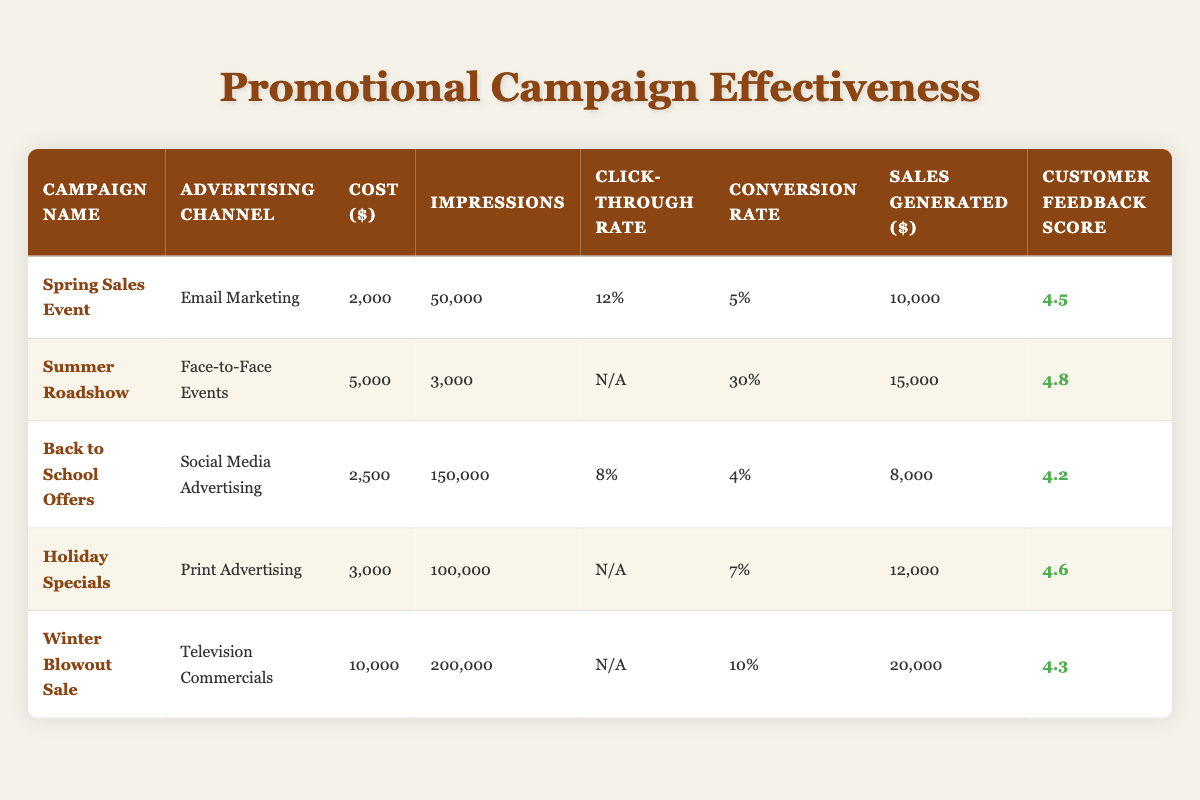What is the cost of the "Summer Roadshow" campaign? The table displays the cost of the "Summer Roadshow" campaign in the corresponding row, which is listed as $5,000.
Answer: 5000 Which advertising channel generated the highest sales? By examining the "Sales Generated" column, the highest value is $20,000 from the "Winter Blowout Sale" campaign, which used Television Commercials as the channel.
Answer: Television Commercials What is the conversion rate for the "Back to School Offers" campaign? The conversion rate for the "Back to School Offers" campaign can be found in its respective row under "Conversion Rate," which is 4%.
Answer: 4% How many impressions did the "Holiday Specials" campaign achieve? Checking the row for "Holiday Specials," the number of impressions is found in the "Impressions" column, which is 100,000.
Answer: 100000 Which campaign had the lowest customer feedback score? The lowest feedback score can be found by comparing all scores in the "Customer Feedback Score" column. "Back to School Offers" with a score of 4.2 has the lowest score.
Answer: 4.2 What channel had the highest conversion rate among all campaigns? The conversion rates are 5%, 30%, 4%, 7%, and 10%. The highest is 30% from the "Summer Roadshow" campaign, using Face-to-Face Events.
Answer: Face-to-Face Events Calculate the average sales generated across all campaigns. To find the average sales, add all sales generated: 10,000 + 15,000 + 8,000 + 12,000 + 20,000 = 65,000. Then, divide by the number of campaigns (5): 65,000 / 5 = 13,000.
Answer: 13000 Is there any campaign where the click-through rate is not available? The "Click-Through Rate" is absent (N/A) for the "Summer Roadshow," "Holiday Specials," and "Winter Blowout Sale," confirming there are campaigns without this data.
Answer: Yes Which campaign had the lowest cost per sale generated? To find the lowest cost per sale, divide the cost by sales generated for each campaign: Spring Sales Event (2000/10000=0.2), Summer Roadshow (5000/15000=0.33), Back to School Offers (2500/8000=0.3125), Holiday Specials (3000/12000=0.25), Winter Blowout Sale (10000/20000=0.5). The lowest cost per sale is from the Spring Sales Event at 0.2.
Answer: Spring Sales Event Which advertising channel had the highest total impressions? Summing the impressions: Email Marketing (50,000) + Face-to-Face Events (3,000) + Social Media Advertising (150,000) + Print Advertising (100,000) + Television Commercials (200,000) gives 503,000. The highest is from Television Commercials with 200,000 impressions.
Answer: Television Commercials 